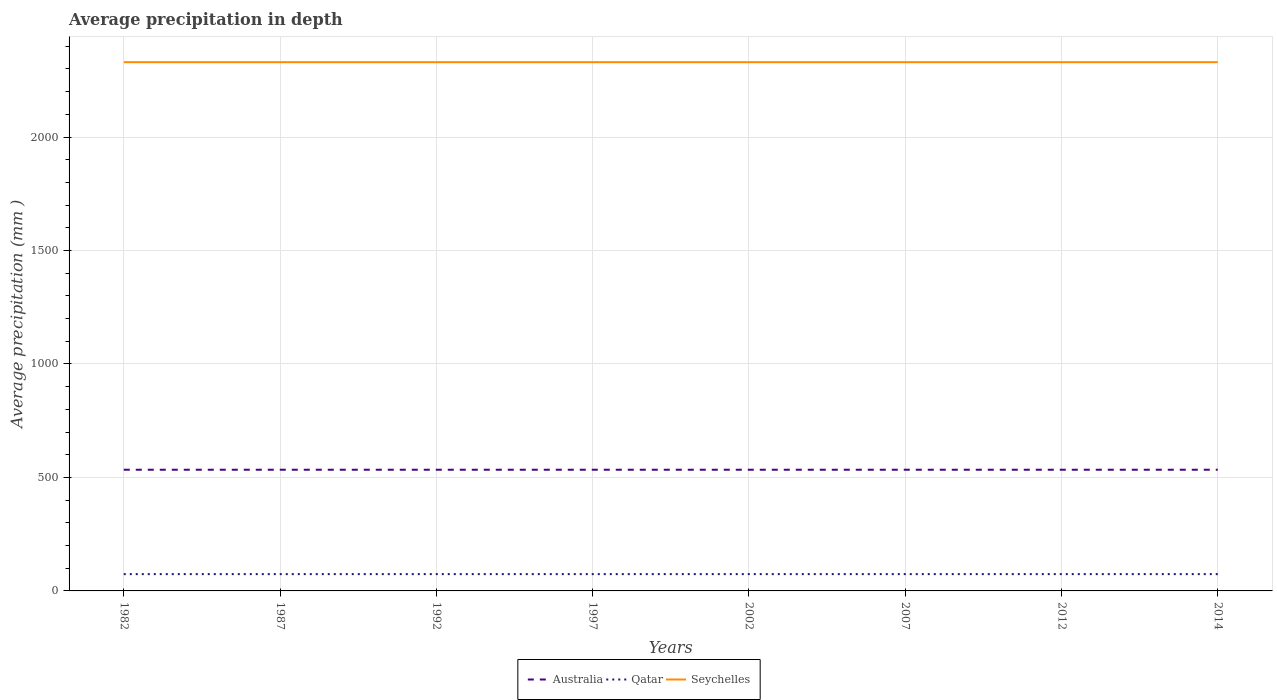Does the line corresponding to Qatar intersect with the line corresponding to Australia?
Provide a succinct answer. No. Across all years, what is the maximum average precipitation in Seychelles?
Your answer should be very brief. 2330. In which year was the average precipitation in Qatar maximum?
Make the answer very short. 1982. What is the total average precipitation in Qatar in the graph?
Provide a short and direct response. 0. What is the difference between the highest and the second highest average precipitation in Australia?
Give a very brief answer. 0. Is the average precipitation in Seychelles strictly greater than the average precipitation in Qatar over the years?
Provide a short and direct response. No. How many lines are there?
Ensure brevity in your answer.  3. What is the difference between two consecutive major ticks on the Y-axis?
Provide a succinct answer. 500. Are the values on the major ticks of Y-axis written in scientific E-notation?
Your response must be concise. No. Does the graph contain any zero values?
Your answer should be compact. No. What is the title of the graph?
Provide a short and direct response. Average precipitation in depth. What is the label or title of the X-axis?
Provide a succinct answer. Years. What is the label or title of the Y-axis?
Give a very brief answer. Average precipitation (mm ). What is the Average precipitation (mm ) of Australia in 1982?
Keep it short and to the point. 534. What is the Average precipitation (mm ) of Seychelles in 1982?
Your answer should be very brief. 2330. What is the Average precipitation (mm ) in Australia in 1987?
Offer a very short reply. 534. What is the Average precipitation (mm ) of Qatar in 1987?
Your answer should be compact. 74. What is the Average precipitation (mm ) in Seychelles in 1987?
Provide a short and direct response. 2330. What is the Average precipitation (mm ) of Australia in 1992?
Provide a succinct answer. 534. What is the Average precipitation (mm ) in Seychelles in 1992?
Make the answer very short. 2330. What is the Average precipitation (mm ) in Australia in 1997?
Ensure brevity in your answer.  534. What is the Average precipitation (mm ) of Seychelles in 1997?
Ensure brevity in your answer.  2330. What is the Average precipitation (mm ) of Australia in 2002?
Offer a terse response. 534. What is the Average precipitation (mm ) of Seychelles in 2002?
Give a very brief answer. 2330. What is the Average precipitation (mm ) of Australia in 2007?
Offer a very short reply. 534. What is the Average precipitation (mm ) of Qatar in 2007?
Give a very brief answer. 74. What is the Average precipitation (mm ) of Seychelles in 2007?
Offer a very short reply. 2330. What is the Average precipitation (mm ) of Australia in 2012?
Provide a succinct answer. 534. What is the Average precipitation (mm ) of Seychelles in 2012?
Offer a terse response. 2330. What is the Average precipitation (mm ) in Australia in 2014?
Ensure brevity in your answer.  534. What is the Average precipitation (mm ) of Qatar in 2014?
Give a very brief answer. 74. What is the Average precipitation (mm ) in Seychelles in 2014?
Offer a terse response. 2330. Across all years, what is the maximum Average precipitation (mm ) in Australia?
Keep it short and to the point. 534. Across all years, what is the maximum Average precipitation (mm ) in Qatar?
Provide a succinct answer. 74. Across all years, what is the maximum Average precipitation (mm ) of Seychelles?
Keep it short and to the point. 2330. Across all years, what is the minimum Average precipitation (mm ) of Australia?
Provide a succinct answer. 534. Across all years, what is the minimum Average precipitation (mm ) of Qatar?
Your response must be concise. 74. Across all years, what is the minimum Average precipitation (mm ) of Seychelles?
Your answer should be very brief. 2330. What is the total Average precipitation (mm ) of Australia in the graph?
Offer a very short reply. 4272. What is the total Average precipitation (mm ) in Qatar in the graph?
Ensure brevity in your answer.  592. What is the total Average precipitation (mm ) of Seychelles in the graph?
Offer a very short reply. 1.86e+04. What is the difference between the Average precipitation (mm ) of Seychelles in 1982 and that in 1987?
Give a very brief answer. 0. What is the difference between the Average precipitation (mm ) in Australia in 1982 and that in 1992?
Your response must be concise. 0. What is the difference between the Average precipitation (mm ) of Qatar in 1982 and that in 1992?
Your answer should be very brief. 0. What is the difference between the Average precipitation (mm ) of Seychelles in 1982 and that in 1992?
Ensure brevity in your answer.  0. What is the difference between the Average precipitation (mm ) of Australia in 1982 and that in 1997?
Offer a very short reply. 0. What is the difference between the Average precipitation (mm ) in Qatar in 1982 and that in 1997?
Offer a very short reply. 0. What is the difference between the Average precipitation (mm ) of Australia in 1982 and that in 2002?
Offer a terse response. 0. What is the difference between the Average precipitation (mm ) of Qatar in 1982 and that in 2002?
Give a very brief answer. 0. What is the difference between the Average precipitation (mm ) of Seychelles in 1982 and that in 2002?
Give a very brief answer. 0. What is the difference between the Average precipitation (mm ) of Qatar in 1982 and that in 2007?
Your answer should be very brief. 0. What is the difference between the Average precipitation (mm ) in Seychelles in 1982 and that in 2007?
Your answer should be compact. 0. What is the difference between the Average precipitation (mm ) of Qatar in 1982 and that in 2012?
Keep it short and to the point. 0. What is the difference between the Average precipitation (mm ) of Seychelles in 1982 and that in 2012?
Keep it short and to the point. 0. What is the difference between the Average precipitation (mm ) of Seychelles in 1982 and that in 2014?
Keep it short and to the point. 0. What is the difference between the Average precipitation (mm ) of Qatar in 1987 and that in 1992?
Offer a terse response. 0. What is the difference between the Average precipitation (mm ) in Australia in 1987 and that in 1997?
Your answer should be compact. 0. What is the difference between the Average precipitation (mm ) in Qatar in 1987 and that in 1997?
Ensure brevity in your answer.  0. What is the difference between the Average precipitation (mm ) in Seychelles in 1987 and that in 2002?
Your answer should be compact. 0. What is the difference between the Average precipitation (mm ) of Australia in 1987 and that in 2007?
Ensure brevity in your answer.  0. What is the difference between the Average precipitation (mm ) of Australia in 1987 and that in 2012?
Provide a short and direct response. 0. What is the difference between the Average precipitation (mm ) in Australia in 1987 and that in 2014?
Keep it short and to the point. 0. What is the difference between the Average precipitation (mm ) in Qatar in 1987 and that in 2014?
Make the answer very short. 0. What is the difference between the Average precipitation (mm ) in Qatar in 1992 and that in 1997?
Your response must be concise. 0. What is the difference between the Average precipitation (mm ) of Qatar in 1992 and that in 2002?
Your answer should be very brief. 0. What is the difference between the Average precipitation (mm ) of Seychelles in 1992 and that in 2002?
Offer a very short reply. 0. What is the difference between the Average precipitation (mm ) of Australia in 1992 and that in 2007?
Provide a succinct answer. 0. What is the difference between the Average precipitation (mm ) in Seychelles in 1992 and that in 2007?
Ensure brevity in your answer.  0. What is the difference between the Average precipitation (mm ) of Australia in 1992 and that in 2012?
Provide a succinct answer. 0. What is the difference between the Average precipitation (mm ) of Qatar in 1992 and that in 2012?
Your response must be concise. 0. What is the difference between the Average precipitation (mm ) of Australia in 1997 and that in 2002?
Your response must be concise. 0. What is the difference between the Average precipitation (mm ) in Qatar in 1997 and that in 2002?
Your response must be concise. 0. What is the difference between the Average precipitation (mm ) of Australia in 1997 and that in 2007?
Make the answer very short. 0. What is the difference between the Average precipitation (mm ) in Qatar in 1997 and that in 2007?
Ensure brevity in your answer.  0. What is the difference between the Average precipitation (mm ) of Australia in 1997 and that in 2014?
Offer a very short reply. 0. What is the difference between the Average precipitation (mm ) in Australia in 2002 and that in 2014?
Provide a short and direct response. 0. What is the difference between the Average precipitation (mm ) of Seychelles in 2002 and that in 2014?
Your answer should be compact. 0. What is the difference between the Average precipitation (mm ) of Seychelles in 2007 and that in 2012?
Your answer should be very brief. 0. What is the difference between the Average precipitation (mm ) of Qatar in 2007 and that in 2014?
Make the answer very short. 0. What is the difference between the Average precipitation (mm ) in Australia in 2012 and that in 2014?
Keep it short and to the point. 0. What is the difference between the Average precipitation (mm ) in Seychelles in 2012 and that in 2014?
Your answer should be compact. 0. What is the difference between the Average precipitation (mm ) of Australia in 1982 and the Average precipitation (mm ) of Qatar in 1987?
Ensure brevity in your answer.  460. What is the difference between the Average precipitation (mm ) in Australia in 1982 and the Average precipitation (mm ) in Seychelles in 1987?
Your answer should be compact. -1796. What is the difference between the Average precipitation (mm ) in Qatar in 1982 and the Average precipitation (mm ) in Seychelles in 1987?
Ensure brevity in your answer.  -2256. What is the difference between the Average precipitation (mm ) in Australia in 1982 and the Average precipitation (mm ) in Qatar in 1992?
Offer a terse response. 460. What is the difference between the Average precipitation (mm ) in Australia in 1982 and the Average precipitation (mm ) in Seychelles in 1992?
Your answer should be very brief. -1796. What is the difference between the Average precipitation (mm ) of Qatar in 1982 and the Average precipitation (mm ) of Seychelles in 1992?
Provide a succinct answer. -2256. What is the difference between the Average precipitation (mm ) in Australia in 1982 and the Average precipitation (mm ) in Qatar in 1997?
Offer a terse response. 460. What is the difference between the Average precipitation (mm ) of Australia in 1982 and the Average precipitation (mm ) of Seychelles in 1997?
Give a very brief answer. -1796. What is the difference between the Average precipitation (mm ) of Qatar in 1982 and the Average precipitation (mm ) of Seychelles in 1997?
Provide a succinct answer. -2256. What is the difference between the Average precipitation (mm ) of Australia in 1982 and the Average precipitation (mm ) of Qatar in 2002?
Ensure brevity in your answer.  460. What is the difference between the Average precipitation (mm ) of Australia in 1982 and the Average precipitation (mm ) of Seychelles in 2002?
Your answer should be very brief. -1796. What is the difference between the Average precipitation (mm ) in Qatar in 1982 and the Average precipitation (mm ) in Seychelles in 2002?
Ensure brevity in your answer.  -2256. What is the difference between the Average precipitation (mm ) in Australia in 1982 and the Average precipitation (mm ) in Qatar in 2007?
Keep it short and to the point. 460. What is the difference between the Average precipitation (mm ) in Australia in 1982 and the Average precipitation (mm ) in Seychelles in 2007?
Your answer should be compact. -1796. What is the difference between the Average precipitation (mm ) in Qatar in 1982 and the Average precipitation (mm ) in Seychelles in 2007?
Your response must be concise. -2256. What is the difference between the Average precipitation (mm ) in Australia in 1982 and the Average precipitation (mm ) in Qatar in 2012?
Ensure brevity in your answer.  460. What is the difference between the Average precipitation (mm ) in Australia in 1982 and the Average precipitation (mm ) in Seychelles in 2012?
Offer a very short reply. -1796. What is the difference between the Average precipitation (mm ) of Qatar in 1982 and the Average precipitation (mm ) of Seychelles in 2012?
Your response must be concise. -2256. What is the difference between the Average precipitation (mm ) in Australia in 1982 and the Average precipitation (mm ) in Qatar in 2014?
Your answer should be compact. 460. What is the difference between the Average precipitation (mm ) in Australia in 1982 and the Average precipitation (mm ) in Seychelles in 2014?
Your response must be concise. -1796. What is the difference between the Average precipitation (mm ) in Qatar in 1982 and the Average precipitation (mm ) in Seychelles in 2014?
Provide a succinct answer. -2256. What is the difference between the Average precipitation (mm ) in Australia in 1987 and the Average precipitation (mm ) in Qatar in 1992?
Offer a very short reply. 460. What is the difference between the Average precipitation (mm ) in Australia in 1987 and the Average precipitation (mm ) in Seychelles in 1992?
Offer a very short reply. -1796. What is the difference between the Average precipitation (mm ) of Qatar in 1987 and the Average precipitation (mm ) of Seychelles in 1992?
Offer a very short reply. -2256. What is the difference between the Average precipitation (mm ) of Australia in 1987 and the Average precipitation (mm ) of Qatar in 1997?
Your answer should be very brief. 460. What is the difference between the Average precipitation (mm ) in Australia in 1987 and the Average precipitation (mm ) in Seychelles in 1997?
Your answer should be compact. -1796. What is the difference between the Average precipitation (mm ) of Qatar in 1987 and the Average precipitation (mm ) of Seychelles in 1997?
Your answer should be very brief. -2256. What is the difference between the Average precipitation (mm ) of Australia in 1987 and the Average precipitation (mm ) of Qatar in 2002?
Offer a very short reply. 460. What is the difference between the Average precipitation (mm ) of Australia in 1987 and the Average precipitation (mm ) of Seychelles in 2002?
Offer a very short reply. -1796. What is the difference between the Average precipitation (mm ) of Qatar in 1987 and the Average precipitation (mm ) of Seychelles in 2002?
Ensure brevity in your answer.  -2256. What is the difference between the Average precipitation (mm ) in Australia in 1987 and the Average precipitation (mm ) in Qatar in 2007?
Offer a very short reply. 460. What is the difference between the Average precipitation (mm ) of Australia in 1987 and the Average precipitation (mm ) of Seychelles in 2007?
Provide a short and direct response. -1796. What is the difference between the Average precipitation (mm ) of Qatar in 1987 and the Average precipitation (mm ) of Seychelles in 2007?
Offer a very short reply. -2256. What is the difference between the Average precipitation (mm ) of Australia in 1987 and the Average precipitation (mm ) of Qatar in 2012?
Offer a very short reply. 460. What is the difference between the Average precipitation (mm ) in Australia in 1987 and the Average precipitation (mm ) in Seychelles in 2012?
Make the answer very short. -1796. What is the difference between the Average precipitation (mm ) in Qatar in 1987 and the Average precipitation (mm ) in Seychelles in 2012?
Your response must be concise. -2256. What is the difference between the Average precipitation (mm ) in Australia in 1987 and the Average precipitation (mm ) in Qatar in 2014?
Your answer should be compact. 460. What is the difference between the Average precipitation (mm ) of Australia in 1987 and the Average precipitation (mm ) of Seychelles in 2014?
Your answer should be compact. -1796. What is the difference between the Average precipitation (mm ) in Qatar in 1987 and the Average precipitation (mm ) in Seychelles in 2014?
Provide a succinct answer. -2256. What is the difference between the Average precipitation (mm ) in Australia in 1992 and the Average precipitation (mm ) in Qatar in 1997?
Provide a succinct answer. 460. What is the difference between the Average precipitation (mm ) of Australia in 1992 and the Average precipitation (mm ) of Seychelles in 1997?
Offer a terse response. -1796. What is the difference between the Average precipitation (mm ) of Qatar in 1992 and the Average precipitation (mm ) of Seychelles in 1997?
Your response must be concise. -2256. What is the difference between the Average precipitation (mm ) of Australia in 1992 and the Average precipitation (mm ) of Qatar in 2002?
Give a very brief answer. 460. What is the difference between the Average precipitation (mm ) of Australia in 1992 and the Average precipitation (mm ) of Seychelles in 2002?
Ensure brevity in your answer.  -1796. What is the difference between the Average precipitation (mm ) in Qatar in 1992 and the Average precipitation (mm ) in Seychelles in 2002?
Offer a terse response. -2256. What is the difference between the Average precipitation (mm ) of Australia in 1992 and the Average precipitation (mm ) of Qatar in 2007?
Offer a terse response. 460. What is the difference between the Average precipitation (mm ) in Australia in 1992 and the Average precipitation (mm ) in Seychelles in 2007?
Make the answer very short. -1796. What is the difference between the Average precipitation (mm ) in Qatar in 1992 and the Average precipitation (mm ) in Seychelles in 2007?
Make the answer very short. -2256. What is the difference between the Average precipitation (mm ) in Australia in 1992 and the Average precipitation (mm ) in Qatar in 2012?
Offer a very short reply. 460. What is the difference between the Average precipitation (mm ) of Australia in 1992 and the Average precipitation (mm ) of Seychelles in 2012?
Provide a succinct answer. -1796. What is the difference between the Average precipitation (mm ) in Qatar in 1992 and the Average precipitation (mm ) in Seychelles in 2012?
Your answer should be compact. -2256. What is the difference between the Average precipitation (mm ) in Australia in 1992 and the Average precipitation (mm ) in Qatar in 2014?
Offer a terse response. 460. What is the difference between the Average precipitation (mm ) of Australia in 1992 and the Average precipitation (mm ) of Seychelles in 2014?
Your response must be concise. -1796. What is the difference between the Average precipitation (mm ) of Qatar in 1992 and the Average precipitation (mm ) of Seychelles in 2014?
Provide a succinct answer. -2256. What is the difference between the Average precipitation (mm ) of Australia in 1997 and the Average precipitation (mm ) of Qatar in 2002?
Your response must be concise. 460. What is the difference between the Average precipitation (mm ) of Australia in 1997 and the Average precipitation (mm ) of Seychelles in 2002?
Your answer should be very brief. -1796. What is the difference between the Average precipitation (mm ) of Qatar in 1997 and the Average precipitation (mm ) of Seychelles in 2002?
Offer a terse response. -2256. What is the difference between the Average precipitation (mm ) of Australia in 1997 and the Average precipitation (mm ) of Qatar in 2007?
Provide a short and direct response. 460. What is the difference between the Average precipitation (mm ) in Australia in 1997 and the Average precipitation (mm ) in Seychelles in 2007?
Keep it short and to the point. -1796. What is the difference between the Average precipitation (mm ) of Qatar in 1997 and the Average precipitation (mm ) of Seychelles in 2007?
Make the answer very short. -2256. What is the difference between the Average precipitation (mm ) of Australia in 1997 and the Average precipitation (mm ) of Qatar in 2012?
Make the answer very short. 460. What is the difference between the Average precipitation (mm ) of Australia in 1997 and the Average precipitation (mm ) of Seychelles in 2012?
Your response must be concise. -1796. What is the difference between the Average precipitation (mm ) of Qatar in 1997 and the Average precipitation (mm ) of Seychelles in 2012?
Offer a very short reply. -2256. What is the difference between the Average precipitation (mm ) in Australia in 1997 and the Average precipitation (mm ) in Qatar in 2014?
Your answer should be very brief. 460. What is the difference between the Average precipitation (mm ) of Australia in 1997 and the Average precipitation (mm ) of Seychelles in 2014?
Offer a terse response. -1796. What is the difference between the Average precipitation (mm ) in Qatar in 1997 and the Average precipitation (mm ) in Seychelles in 2014?
Keep it short and to the point. -2256. What is the difference between the Average precipitation (mm ) in Australia in 2002 and the Average precipitation (mm ) in Qatar in 2007?
Provide a succinct answer. 460. What is the difference between the Average precipitation (mm ) of Australia in 2002 and the Average precipitation (mm ) of Seychelles in 2007?
Give a very brief answer. -1796. What is the difference between the Average precipitation (mm ) in Qatar in 2002 and the Average precipitation (mm ) in Seychelles in 2007?
Provide a short and direct response. -2256. What is the difference between the Average precipitation (mm ) in Australia in 2002 and the Average precipitation (mm ) in Qatar in 2012?
Your answer should be compact. 460. What is the difference between the Average precipitation (mm ) in Australia in 2002 and the Average precipitation (mm ) in Seychelles in 2012?
Your response must be concise. -1796. What is the difference between the Average precipitation (mm ) in Qatar in 2002 and the Average precipitation (mm ) in Seychelles in 2012?
Provide a short and direct response. -2256. What is the difference between the Average precipitation (mm ) in Australia in 2002 and the Average precipitation (mm ) in Qatar in 2014?
Make the answer very short. 460. What is the difference between the Average precipitation (mm ) in Australia in 2002 and the Average precipitation (mm ) in Seychelles in 2014?
Provide a succinct answer. -1796. What is the difference between the Average precipitation (mm ) of Qatar in 2002 and the Average precipitation (mm ) of Seychelles in 2014?
Provide a short and direct response. -2256. What is the difference between the Average precipitation (mm ) of Australia in 2007 and the Average precipitation (mm ) of Qatar in 2012?
Provide a short and direct response. 460. What is the difference between the Average precipitation (mm ) of Australia in 2007 and the Average precipitation (mm ) of Seychelles in 2012?
Offer a very short reply. -1796. What is the difference between the Average precipitation (mm ) in Qatar in 2007 and the Average precipitation (mm ) in Seychelles in 2012?
Your answer should be compact. -2256. What is the difference between the Average precipitation (mm ) of Australia in 2007 and the Average precipitation (mm ) of Qatar in 2014?
Provide a succinct answer. 460. What is the difference between the Average precipitation (mm ) of Australia in 2007 and the Average precipitation (mm ) of Seychelles in 2014?
Ensure brevity in your answer.  -1796. What is the difference between the Average precipitation (mm ) of Qatar in 2007 and the Average precipitation (mm ) of Seychelles in 2014?
Make the answer very short. -2256. What is the difference between the Average precipitation (mm ) in Australia in 2012 and the Average precipitation (mm ) in Qatar in 2014?
Offer a very short reply. 460. What is the difference between the Average precipitation (mm ) in Australia in 2012 and the Average precipitation (mm ) in Seychelles in 2014?
Provide a succinct answer. -1796. What is the difference between the Average precipitation (mm ) of Qatar in 2012 and the Average precipitation (mm ) of Seychelles in 2014?
Make the answer very short. -2256. What is the average Average precipitation (mm ) in Australia per year?
Offer a very short reply. 534. What is the average Average precipitation (mm ) in Seychelles per year?
Make the answer very short. 2330. In the year 1982, what is the difference between the Average precipitation (mm ) of Australia and Average precipitation (mm ) of Qatar?
Give a very brief answer. 460. In the year 1982, what is the difference between the Average precipitation (mm ) in Australia and Average precipitation (mm ) in Seychelles?
Make the answer very short. -1796. In the year 1982, what is the difference between the Average precipitation (mm ) of Qatar and Average precipitation (mm ) of Seychelles?
Offer a terse response. -2256. In the year 1987, what is the difference between the Average precipitation (mm ) of Australia and Average precipitation (mm ) of Qatar?
Provide a short and direct response. 460. In the year 1987, what is the difference between the Average precipitation (mm ) of Australia and Average precipitation (mm ) of Seychelles?
Make the answer very short. -1796. In the year 1987, what is the difference between the Average precipitation (mm ) of Qatar and Average precipitation (mm ) of Seychelles?
Your answer should be very brief. -2256. In the year 1992, what is the difference between the Average precipitation (mm ) of Australia and Average precipitation (mm ) of Qatar?
Provide a succinct answer. 460. In the year 1992, what is the difference between the Average precipitation (mm ) in Australia and Average precipitation (mm ) in Seychelles?
Provide a succinct answer. -1796. In the year 1992, what is the difference between the Average precipitation (mm ) of Qatar and Average precipitation (mm ) of Seychelles?
Your answer should be compact. -2256. In the year 1997, what is the difference between the Average precipitation (mm ) in Australia and Average precipitation (mm ) in Qatar?
Provide a succinct answer. 460. In the year 1997, what is the difference between the Average precipitation (mm ) of Australia and Average precipitation (mm ) of Seychelles?
Your answer should be compact. -1796. In the year 1997, what is the difference between the Average precipitation (mm ) of Qatar and Average precipitation (mm ) of Seychelles?
Provide a succinct answer. -2256. In the year 2002, what is the difference between the Average precipitation (mm ) of Australia and Average precipitation (mm ) of Qatar?
Make the answer very short. 460. In the year 2002, what is the difference between the Average precipitation (mm ) in Australia and Average precipitation (mm ) in Seychelles?
Offer a very short reply. -1796. In the year 2002, what is the difference between the Average precipitation (mm ) in Qatar and Average precipitation (mm ) in Seychelles?
Keep it short and to the point. -2256. In the year 2007, what is the difference between the Average precipitation (mm ) of Australia and Average precipitation (mm ) of Qatar?
Keep it short and to the point. 460. In the year 2007, what is the difference between the Average precipitation (mm ) of Australia and Average precipitation (mm ) of Seychelles?
Ensure brevity in your answer.  -1796. In the year 2007, what is the difference between the Average precipitation (mm ) of Qatar and Average precipitation (mm ) of Seychelles?
Your answer should be very brief. -2256. In the year 2012, what is the difference between the Average precipitation (mm ) in Australia and Average precipitation (mm ) in Qatar?
Your answer should be compact. 460. In the year 2012, what is the difference between the Average precipitation (mm ) in Australia and Average precipitation (mm ) in Seychelles?
Keep it short and to the point. -1796. In the year 2012, what is the difference between the Average precipitation (mm ) of Qatar and Average precipitation (mm ) of Seychelles?
Offer a terse response. -2256. In the year 2014, what is the difference between the Average precipitation (mm ) of Australia and Average precipitation (mm ) of Qatar?
Make the answer very short. 460. In the year 2014, what is the difference between the Average precipitation (mm ) in Australia and Average precipitation (mm ) in Seychelles?
Offer a very short reply. -1796. In the year 2014, what is the difference between the Average precipitation (mm ) in Qatar and Average precipitation (mm ) in Seychelles?
Keep it short and to the point. -2256. What is the ratio of the Average precipitation (mm ) in Seychelles in 1982 to that in 1997?
Offer a very short reply. 1. What is the ratio of the Average precipitation (mm ) in Australia in 1982 to that in 2002?
Keep it short and to the point. 1. What is the ratio of the Average precipitation (mm ) of Seychelles in 1982 to that in 2002?
Your response must be concise. 1. What is the ratio of the Average precipitation (mm ) of Qatar in 1982 to that in 2007?
Your response must be concise. 1. What is the ratio of the Average precipitation (mm ) of Seychelles in 1982 to that in 2007?
Your answer should be compact. 1. What is the ratio of the Average precipitation (mm ) of Australia in 1982 to that in 2012?
Make the answer very short. 1. What is the ratio of the Average precipitation (mm ) in Qatar in 1982 to that in 2012?
Offer a very short reply. 1. What is the ratio of the Average precipitation (mm ) in Qatar in 1982 to that in 2014?
Ensure brevity in your answer.  1. What is the ratio of the Average precipitation (mm ) in Seychelles in 1987 to that in 1992?
Provide a short and direct response. 1. What is the ratio of the Average precipitation (mm ) in Qatar in 1987 to that in 1997?
Your answer should be very brief. 1. What is the ratio of the Average precipitation (mm ) of Seychelles in 1987 to that in 1997?
Your response must be concise. 1. What is the ratio of the Average precipitation (mm ) in Qatar in 1987 to that in 2002?
Ensure brevity in your answer.  1. What is the ratio of the Average precipitation (mm ) of Seychelles in 1987 to that in 2002?
Provide a succinct answer. 1. What is the ratio of the Average precipitation (mm ) of Qatar in 1987 to that in 2007?
Your answer should be compact. 1. What is the ratio of the Average precipitation (mm ) of Australia in 1987 to that in 2012?
Your response must be concise. 1. What is the ratio of the Average precipitation (mm ) of Qatar in 1987 to that in 2012?
Give a very brief answer. 1. What is the ratio of the Average precipitation (mm ) in Australia in 1987 to that in 2014?
Ensure brevity in your answer.  1. What is the ratio of the Average precipitation (mm ) of Australia in 1992 to that in 1997?
Make the answer very short. 1. What is the ratio of the Average precipitation (mm ) in Seychelles in 1992 to that in 1997?
Offer a very short reply. 1. What is the ratio of the Average precipitation (mm ) in Qatar in 1992 to that in 2002?
Your response must be concise. 1. What is the ratio of the Average precipitation (mm ) in Seychelles in 1992 to that in 2002?
Give a very brief answer. 1. What is the ratio of the Average precipitation (mm ) in Australia in 1992 to that in 2007?
Make the answer very short. 1. What is the ratio of the Average precipitation (mm ) of Qatar in 1992 to that in 2014?
Your answer should be very brief. 1. What is the ratio of the Average precipitation (mm ) of Seychelles in 1992 to that in 2014?
Provide a succinct answer. 1. What is the ratio of the Average precipitation (mm ) in Australia in 1997 to that in 2002?
Give a very brief answer. 1. What is the ratio of the Average precipitation (mm ) of Seychelles in 1997 to that in 2002?
Provide a succinct answer. 1. What is the ratio of the Average precipitation (mm ) in Australia in 1997 to that in 2007?
Your answer should be very brief. 1. What is the ratio of the Average precipitation (mm ) of Qatar in 1997 to that in 2007?
Make the answer very short. 1. What is the ratio of the Average precipitation (mm ) in Qatar in 1997 to that in 2012?
Your answer should be very brief. 1. What is the ratio of the Average precipitation (mm ) of Australia in 1997 to that in 2014?
Your answer should be compact. 1. What is the ratio of the Average precipitation (mm ) of Qatar in 1997 to that in 2014?
Offer a very short reply. 1. What is the ratio of the Average precipitation (mm ) in Seychelles in 1997 to that in 2014?
Your answer should be very brief. 1. What is the ratio of the Average precipitation (mm ) of Qatar in 2002 to that in 2007?
Offer a terse response. 1. What is the ratio of the Average precipitation (mm ) of Seychelles in 2002 to that in 2007?
Offer a very short reply. 1. What is the ratio of the Average precipitation (mm ) in Qatar in 2002 to that in 2012?
Keep it short and to the point. 1. What is the ratio of the Average precipitation (mm ) of Seychelles in 2002 to that in 2014?
Make the answer very short. 1. What is the ratio of the Average precipitation (mm ) in Australia in 2007 to that in 2012?
Your response must be concise. 1. What is the ratio of the Average precipitation (mm ) of Qatar in 2007 to that in 2012?
Make the answer very short. 1. What is the ratio of the Average precipitation (mm ) in Seychelles in 2007 to that in 2014?
Your response must be concise. 1. What is the ratio of the Average precipitation (mm ) in Australia in 2012 to that in 2014?
Provide a short and direct response. 1. What is the ratio of the Average precipitation (mm ) in Qatar in 2012 to that in 2014?
Your response must be concise. 1. What is the difference between the highest and the lowest Average precipitation (mm ) of Australia?
Make the answer very short. 0. 